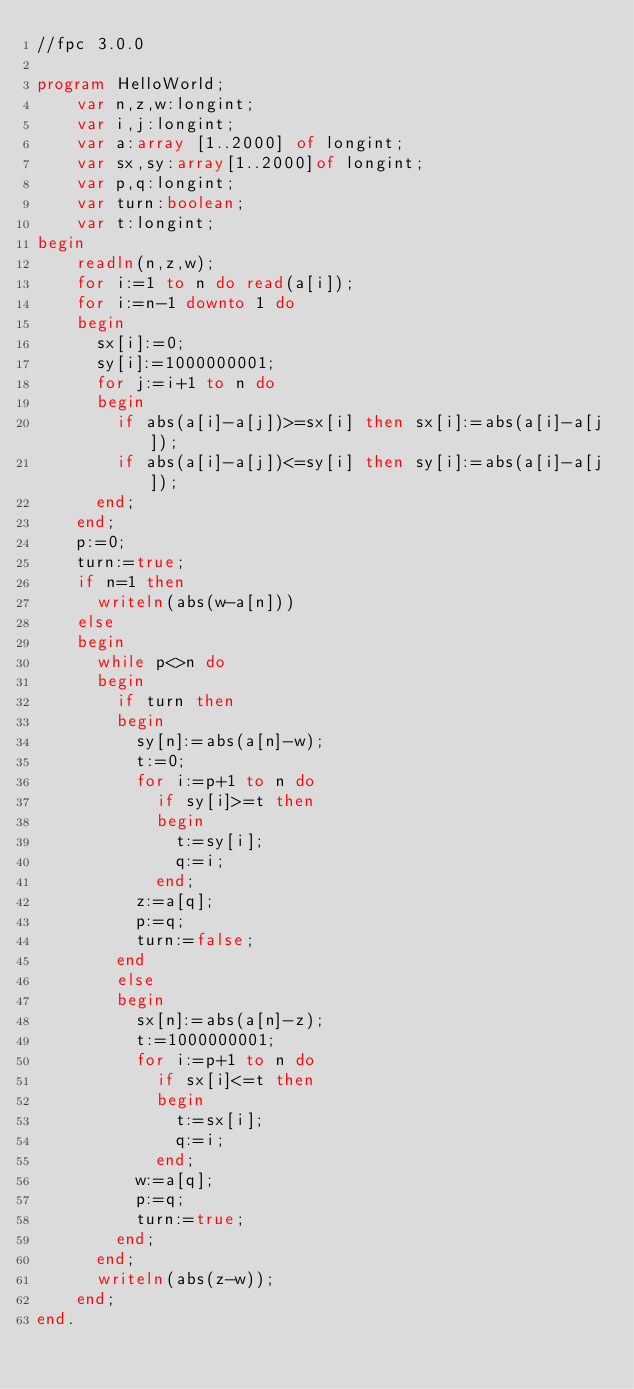<code> <loc_0><loc_0><loc_500><loc_500><_Pascal_>//fpc 3.0.0

program HelloWorld;
    var n,z,w:longint;
    var i,j:longint;
    var a:array [1..2000] of longint;
    var sx,sy:array[1..2000]of longint;
    var p,q:longint;
    var turn:boolean;
    var t:longint;
begin
    readln(n,z,w);
    for i:=1 to n do read(a[i]);
    for i:=n-1 downto 1 do
    begin
      sx[i]:=0;
      sy[i]:=1000000001;
      for j:=i+1 to n do
      begin
        if abs(a[i]-a[j])>=sx[i] then sx[i]:=abs(a[i]-a[j]);
        if abs(a[i]-a[j])<=sy[i] then sy[i]:=abs(a[i]-a[j]);
      end;
    end;
    p:=0;
    turn:=true;
    if n=1 then
      writeln(abs(w-a[n]))
    else
    begin
      while p<>n do
      begin
        if turn then
        begin
          sy[n]:=abs(a[n]-w);
          t:=0;
          for i:=p+1 to n do
            if sy[i]>=t then
            begin
              t:=sy[i];
              q:=i;
            end;
          z:=a[q];
          p:=q;
          turn:=false;
        end
        else
        begin
          sx[n]:=abs(a[n]-z);
          t:=1000000001;
          for i:=p+1 to n do
            if sx[i]<=t then
            begin
              t:=sx[i];
              q:=i;
            end;
          w:=a[q];
          p:=q;
          turn:=true;
        end;
      end;
      writeln(abs(z-w));
    end;
end.
</code> 